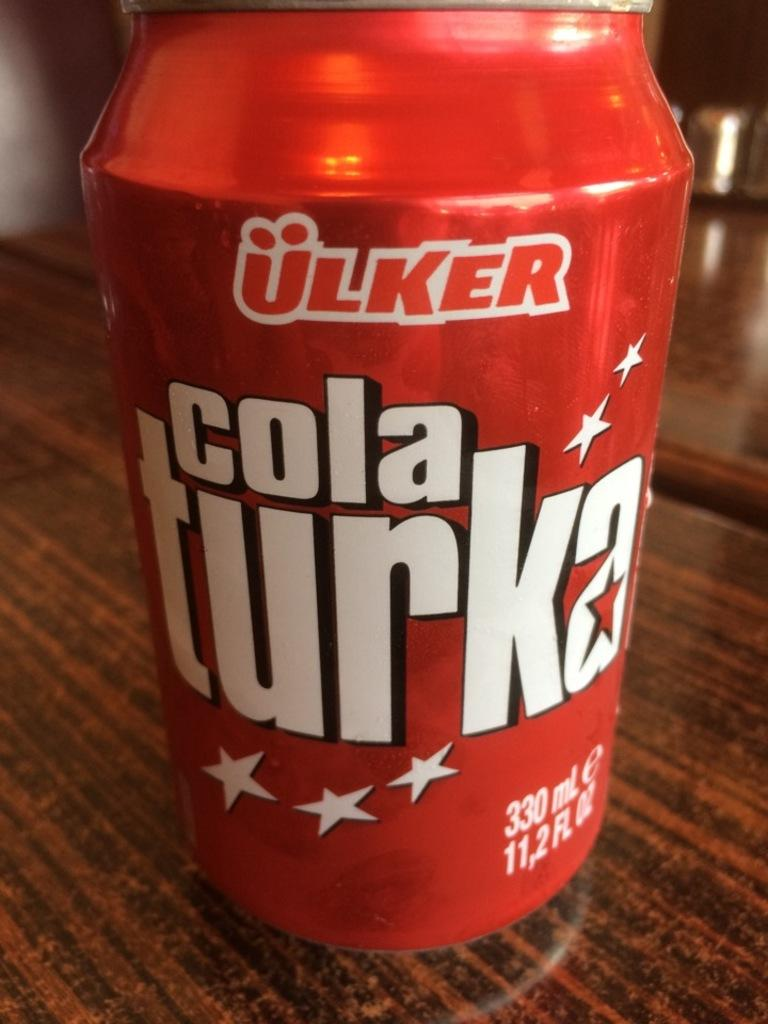<image>
Give a short and clear explanation of the subsequent image. A cola turka drink made by ulker a 11.2 fl oz can. 